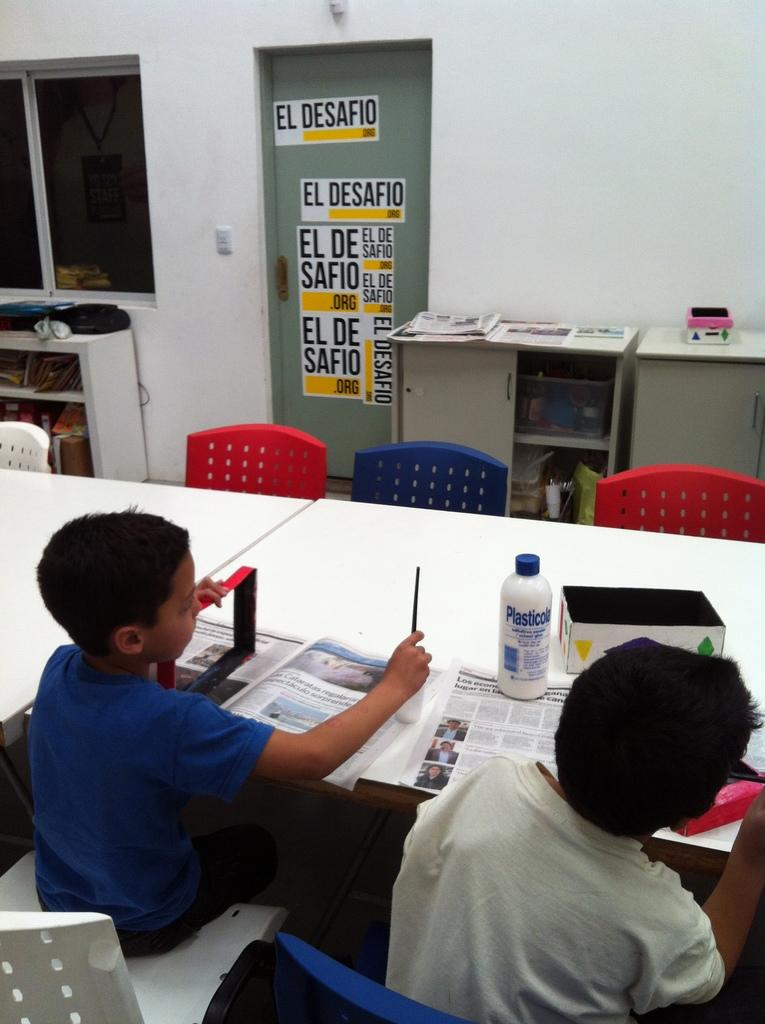<image>
Give a short and clear explanation of the subsequent image. Two children sit at a table with signs on a door in the background reading EL DESAFIO. 